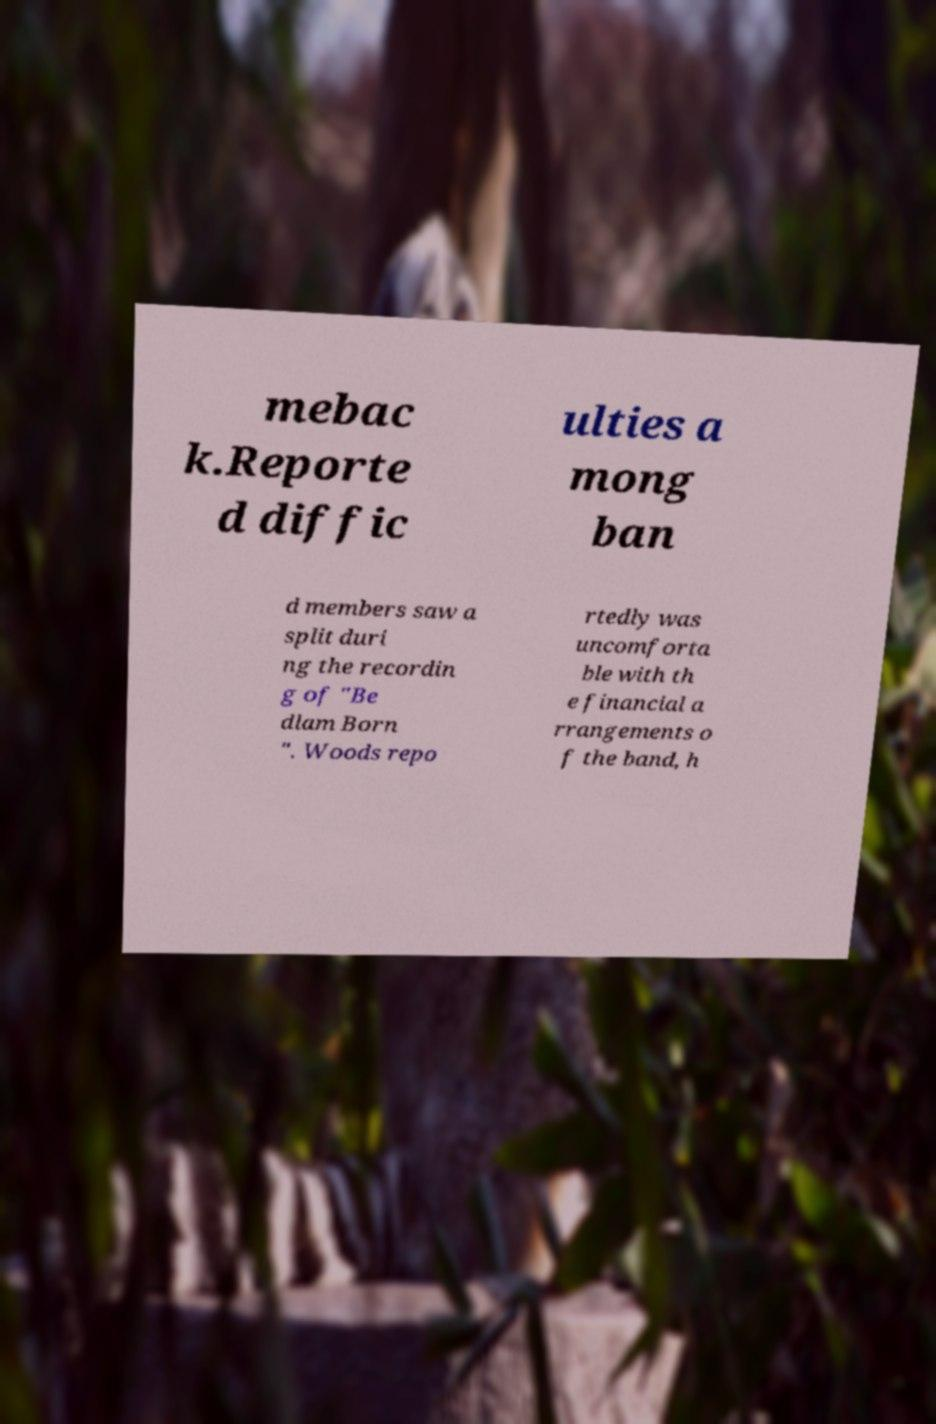For documentation purposes, I need the text within this image transcribed. Could you provide that? mebac k.Reporte d diffic ulties a mong ban d members saw a split duri ng the recordin g of "Be dlam Born ". Woods repo rtedly was uncomforta ble with th e financial a rrangements o f the band, h 